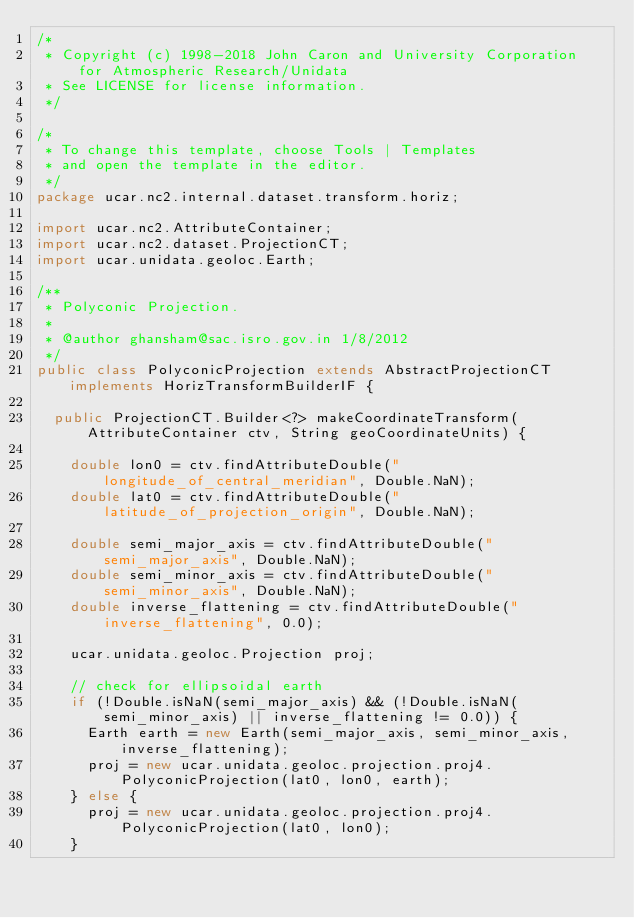Convert code to text. <code><loc_0><loc_0><loc_500><loc_500><_Java_>/*
 * Copyright (c) 1998-2018 John Caron and University Corporation for Atmospheric Research/Unidata
 * See LICENSE for license information.
 */

/*
 * To change this template, choose Tools | Templates
 * and open the template in the editor.
 */
package ucar.nc2.internal.dataset.transform.horiz;

import ucar.nc2.AttributeContainer;
import ucar.nc2.dataset.ProjectionCT;
import ucar.unidata.geoloc.Earth;

/**
 * Polyconic Projection.
 * 
 * @author ghansham@sac.isro.gov.in 1/8/2012
 */
public class PolyconicProjection extends AbstractProjectionCT implements HorizTransformBuilderIF {

  public ProjectionCT.Builder<?> makeCoordinateTransform(AttributeContainer ctv, String geoCoordinateUnits) {

    double lon0 = ctv.findAttributeDouble("longitude_of_central_meridian", Double.NaN);
    double lat0 = ctv.findAttributeDouble("latitude_of_projection_origin", Double.NaN);

    double semi_major_axis = ctv.findAttributeDouble("semi_major_axis", Double.NaN);
    double semi_minor_axis = ctv.findAttributeDouble("semi_minor_axis", Double.NaN);
    double inverse_flattening = ctv.findAttributeDouble("inverse_flattening", 0.0);

    ucar.unidata.geoloc.Projection proj;

    // check for ellipsoidal earth
    if (!Double.isNaN(semi_major_axis) && (!Double.isNaN(semi_minor_axis) || inverse_flattening != 0.0)) {
      Earth earth = new Earth(semi_major_axis, semi_minor_axis, inverse_flattening);
      proj = new ucar.unidata.geoloc.projection.proj4.PolyconicProjection(lat0, lon0, earth);
    } else {
      proj = new ucar.unidata.geoloc.projection.proj4.PolyconicProjection(lat0, lon0);
    }
</code> 